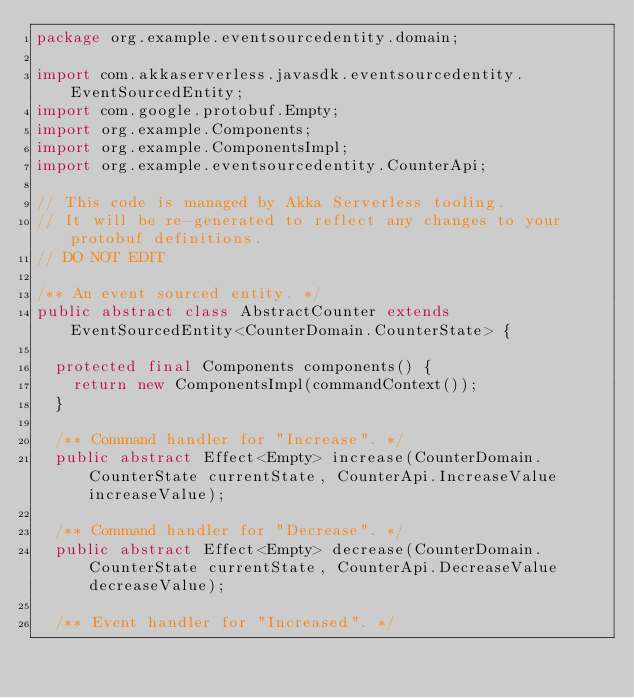<code> <loc_0><loc_0><loc_500><loc_500><_Java_>package org.example.eventsourcedentity.domain;

import com.akkaserverless.javasdk.eventsourcedentity.EventSourcedEntity;
import com.google.protobuf.Empty;
import org.example.Components;
import org.example.ComponentsImpl;
import org.example.eventsourcedentity.CounterApi;

// This code is managed by Akka Serverless tooling.
// It will be re-generated to reflect any changes to your protobuf definitions.
// DO NOT EDIT

/** An event sourced entity. */
public abstract class AbstractCounter extends EventSourcedEntity<CounterDomain.CounterState> {

  protected final Components components() {
    return new ComponentsImpl(commandContext());
  }

  /** Command handler for "Increase". */
  public abstract Effect<Empty> increase(CounterDomain.CounterState currentState, CounterApi.IncreaseValue increaseValue);

  /** Command handler for "Decrease". */
  public abstract Effect<Empty> decrease(CounterDomain.CounterState currentState, CounterApi.DecreaseValue decreaseValue);

  /** Event handler for "Increased". */</code> 